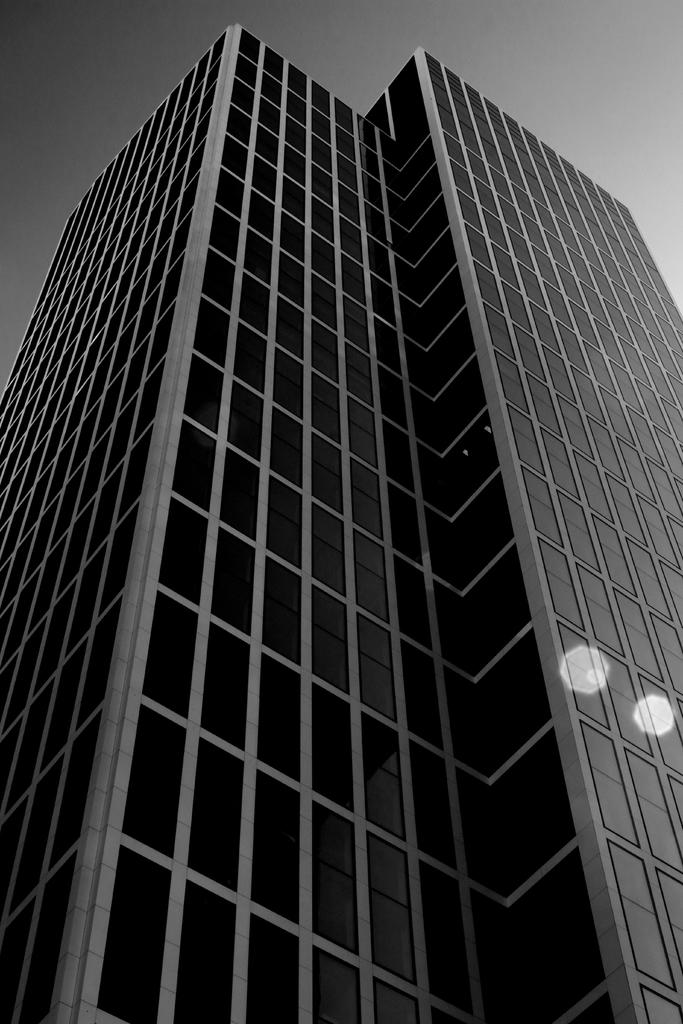What is the color scheme of the image? The image is black and white. Where was the image taken from? The image was taken from outside of a building. From what height was the image taken? The image was taken from a high vantage point. What is visible at the top of the image? The sky is visible at the top of the image. How many balls are being used in the society depicted in the image? There is no depiction of a society or balls in the image; it is a black and white image taken from outside a building at a high vantage point. 